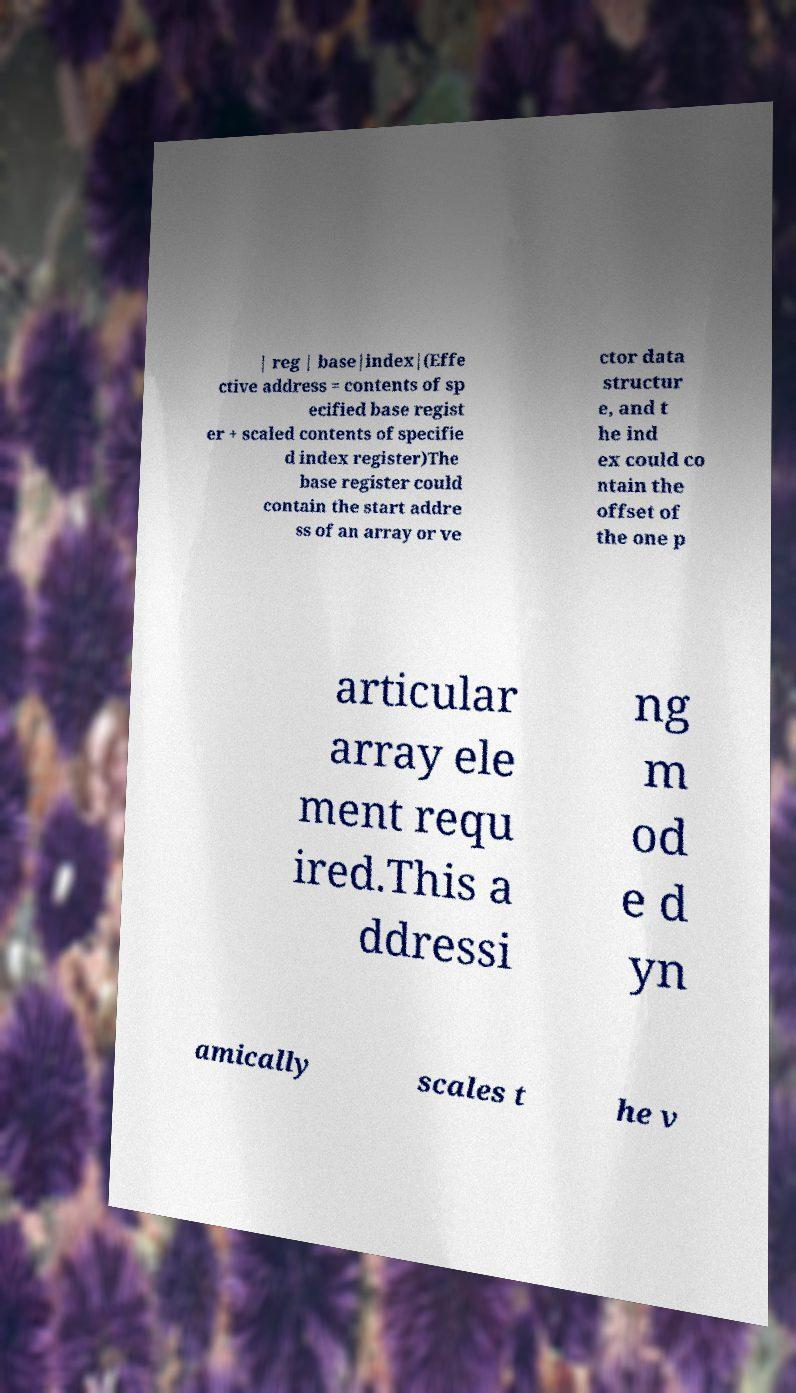Could you extract and type out the text from this image? | reg | base|index|(Effe ctive address = contents of sp ecified base regist er + scaled contents of specifie d index register)The base register could contain the start addre ss of an array or ve ctor data structur e, and t he ind ex could co ntain the offset of the one p articular array ele ment requ ired.This a ddressi ng m od e d yn amically scales t he v 